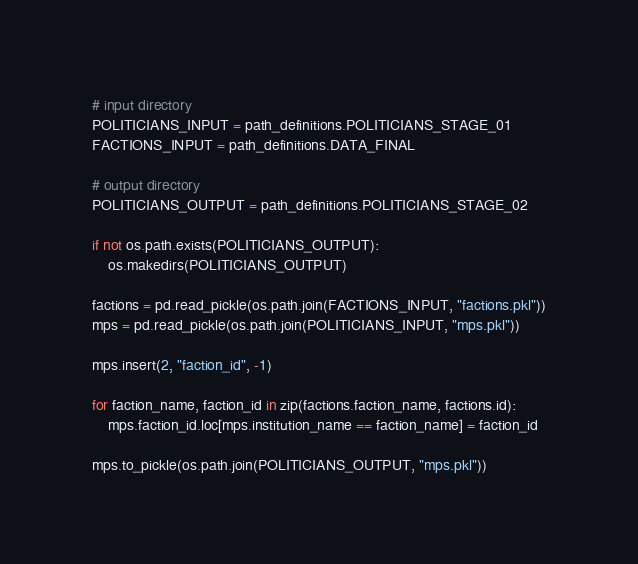<code> <loc_0><loc_0><loc_500><loc_500><_Python_>
# input directory
POLITICIANS_INPUT = path_definitions.POLITICIANS_STAGE_01
FACTIONS_INPUT = path_definitions.DATA_FINAL

# output directory
POLITICIANS_OUTPUT = path_definitions.POLITICIANS_STAGE_02

if not os.path.exists(POLITICIANS_OUTPUT):
    os.makedirs(POLITICIANS_OUTPUT)

factions = pd.read_pickle(os.path.join(FACTIONS_INPUT, "factions.pkl"))
mps = pd.read_pickle(os.path.join(POLITICIANS_INPUT, "mps.pkl"))

mps.insert(2, "faction_id", -1)

for faction_name, faction_id in zip(factions.faction_name, factions.id):
    mps.faction_id.loc[mps.institution_name == faction_name] = faction_id

mps.to_pickle(os.path.join(POLITICIANS_OUTPUT, "mps.pkl"))
</code> 